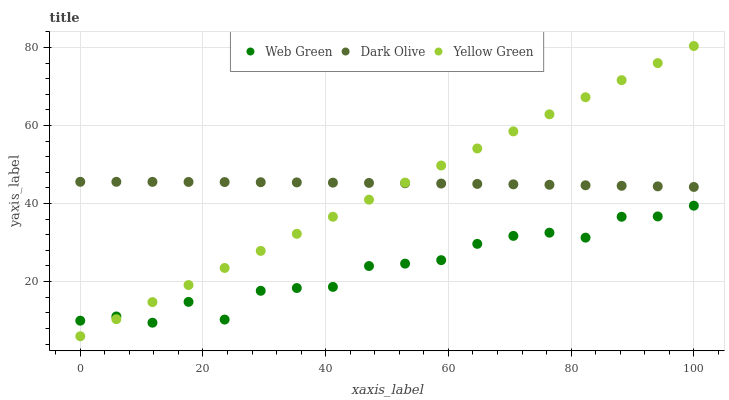Does Web Green have the minimum area under the curve?
Answer yes or no. Yes. Does Dark Olive have the maximum area under the curve?
Answer yes or no. Yes. Does Yellow Green have the minimum area under the curve?
Answer yes or no. No. Does Yellow Green have the maximum area under the curve?
Answer yes or no. No. Is Yellow Green the smoothest?
Answer yes or no. Yes. Is Web Green the roughest?
Answer yes or no. Yes. Is Web Green the smoothest?
Answer yes or no. No. Is Yellow Green the roughest?
Answer yes or no. No. Does Yellow Green have the lowest value?
Answer yes or no. Yes. Does Web Green have the lowest value?
Answer yes or no. No. Does Yellow Green have the highest value?
Answer yes or no. Yes. Does Web Green have the highest value?
Answer yes or no. No. Is Web Green less than Dark Olive?
Answer yes or no. Yes. Is Dark Olive greater than Web Green?
Answer yes or no. Yes. Does Yellow Green intersect Dark Olive?
Answer yes or no. Yes. Is Yellow Green less than Dark Olive?
Answer yes or no. No. Is Yellow Green greater than Dark Olive?
Answer yes or no. No. Does Web Green intersect Dark Olive?
Answer yes or no. No. 